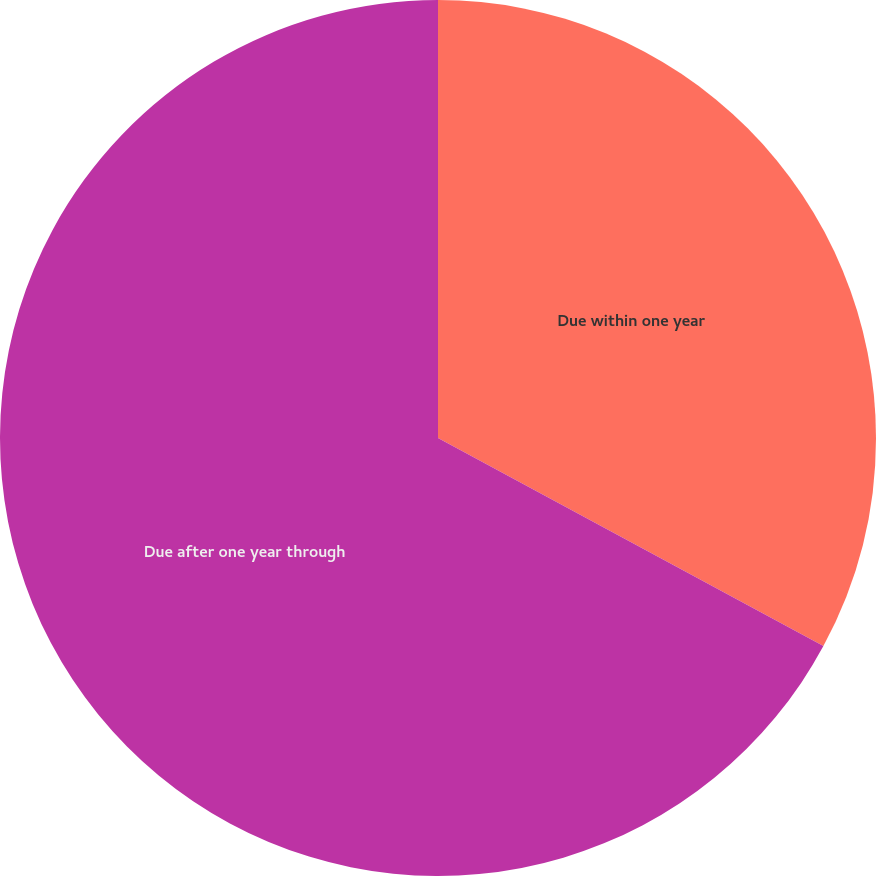Convert chart to OTSL. <chart><loc_0><loc_0><loc_500><loc_500><pie_chart><fcel>Due within one year<fcel>Due after one year through<nl><fcel>32.88%<fcel>67.12%<nl></chart> 